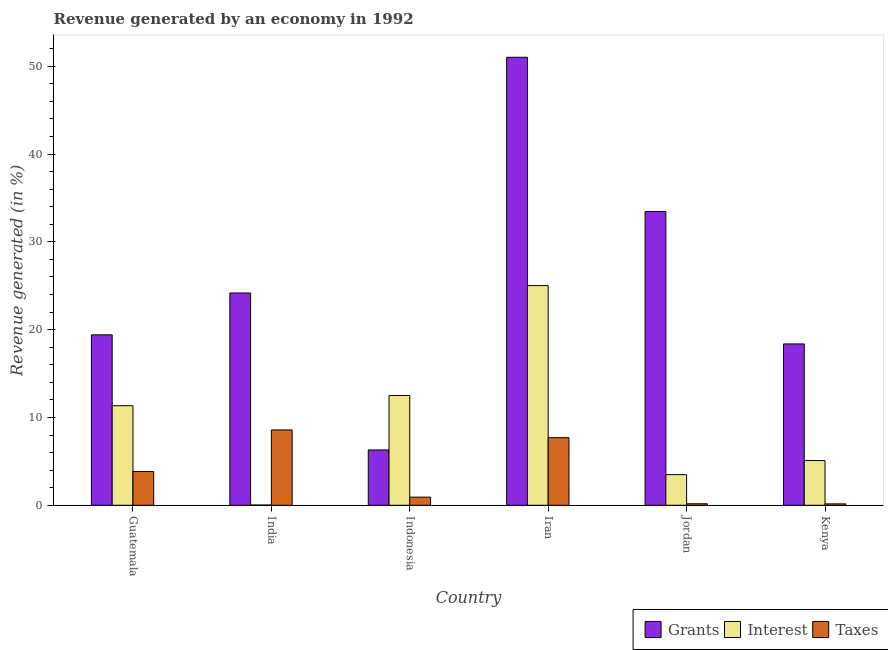How many groups of bars are there?
Keep it short and to the point. 6. Are the number of bars on each tick of the X-axis equal?
Make the answer very short. Yes. How many bars are there on the 5th tick from the right?
Offer a terse response. 3. What is the label of the 4th group of bars from the left?
Your response must be concise. Iran. What is the percentage of revenue generated by taxes in Iran?
Your response must be concise. 7.7. Across all countries, what is the maximum percentage of revenue generated by taxes?
Offer a terse response. 8.58. Across all countries, what is the minimum percentage of revenue generated by grants?
Keep it short and to the point. 6.3. In which country was the percentage of revenue generated by taxes maximum?
Make the answer very short. India. What is the total percentage of revenue generated by grants in the graph?
Provide a short and direct response. 152.74. What is the difference between the percentage of revenue generated by taxes in India and that in Indonesia?
Your answer should be very brief. 7.65. What is the difference between the percentage of revenue generated by grants in Iran and the percentage of revenue generated by taxes in Jordan?
Ensure brevity in your answer.  50.85. What is the average percentage of revenue generated by taxes per country?
Offer a very short reply. 3.56. What is the difference between the percentage of revenue generated by interest and percentage of revenue generated by grants in Iran?
Your answer should be compact. -26. In how many countries, is the percentage of revenue generated by grants greater than 36 %?
Offer a terse response. 1. What is the ratio of the percentage of revenue generated by interest in Indonesia to that in Iran?
Provide a short and direct response. 0.5. Is the percentage of revenue generated by interest in Iran less than that in Kenya?
Give a very brief answer. No. What is the difference between the highest and the second highest percentage of revenue generated by grants?
Keep it short and to the point. 17.56. What is the difference between the highest and the lowest percentage of revenue generated by taxes?
Make the answer very short. 8.42. Is the sum of the percentage of revenue generated by grants in Guatemala and Indonesia greater than the maximum percentage of revenue generated by interest across all countries?
Your answer should be very brief. Yes. What does the 1st bar from the left in India represents?
Offer a terse response. Grants. What does the 2nd bar from the right in Kenya represents?
Make the answer very short. Interest. Is it the case that in every country, the sum of the percentage of revenue generated by grants and percentage of revenue generated by interest is greater than the percentage of revenue generated by taxes?
Offer a terse response. Yes. How many countries are there in the graph?
Your answer should be very brief. 6. Are the values on the major ticks of Y-axis written in scientific E-notation?
Offer a very short reply. No. Does the graph contain any zero values?
Your answer should be compact. No. Does the graph contain grids?
Provide a succinct answer. No. What is the title of the graph?
Your response must be concise. Revenue generated by an economy in 1992. Does "Negligence towards kids" appear as one of the legend labels in the graph?
Provide a succinct answer. No. What is the label or title of the X-axis?
Provide a short and direct response. Country. What is the label or title of the Y-axis?
Make the answer very short. Revenue generated (in %). What is the Revenue generated (in %) of Grants in Guatemala?
Keep it short and to the point. 19.41. What is the Revenue generated (in %) in Interest in Guatemala?
Offer a very short reply. 11.34. What is the Revenue generated (in %) in Taxes in Guatemala?
Make the answer very short. 3.84. What is the Revenue generated (in %) of Grants in India?
Provide a succinct answer. 24.18. What is the Revenue generated (in %) of Interest in India?
Offer a very short reply. 0.02. What is the Revenue generated (in %) in Taxes in India?
Provide a succinct answer. 8.58. What is the Revenue generated (in %) of Grants in Indonesia?
Offer a very short reply. 6.3. What is the Revenue generated (in %) in Interest in Indonesia?
Your answer should be compact. 12.5. What is the Revenue generated (in %) of Taxes in Indonesia?
Offer a terse response. 0.93. What is the Revenue generated (in %) of Grants in Iran?
Offer a terse response. 51.02. What is the Revenue generated (in %) of Interest in Iran?
Provide a short and direct response. 25.02. What is the Revenue generated (in %) in Taxes in Iran?
Keep it short and to the point. 7.7. What is the Revenue generated (in %) in Grants in Jordan?
Make the answer very short. 33.46. What is the Revenue generated (in %) of Interest in Jordan?
Ensure brevity in your answer.  3.49. What is the Revenue generated (in %) of Taxes in Jordan?
Provide a succinct answer. 0.17. What is the Revenue generated (in %) in Grants in Kenya?
Make the answer very short. 18.37. What is the Revenue generated (in %) in Interest in Kenya?
Your response must be concise. 5.09. What is the Revenue generated (in %) in Taxes in Kenya?
Provide a short and direct response. 0.16. Across all countries, what is the maximum Revenue generated (in %) of Grants?
Make the answer very short. 51.02. Across all countries, what is the maximum Revenue generated (in %) of Interest?
Ensure brevity in your answer.  25.02. Across all countries, what is the maximum Revenue generated (in %) in Taxes?
Keep it short and to the point. 8.58. Across all countries, what is the minimum Revenue generated (in %) of Grants?
Your response must be concise. 6.3. Across all countries, what is the minimum Revenue generated (in %) of Interest?
Offer a terse response. 0.02. Across all countries, what is the minimum Revenue generated (in %) in Taxes?
Keep it short and to the point. 0.16. What is the total Revenue generated (in %) in Grants in the graph?
Make the answer very short. 152.74. What is the total Revenue generated (in %) in Interest in the graph?
Keep it short and to the point. 57.46. What is the total Revenue generated (in %) in Taxes in the graph?
Offer a very short reply. 21.38. What is the difference between the Revenue generated (in %) in Grants in Guatemala and that in India?
Provide a short and direct response. -4.76. What is the difference between the Revenue generated (in %) of Interest in Guatemala and that in India?
Ensure brevity in your answer.  11.32. What is the difference between the Revenue generated (in %) in Taxes in Guatemala and that in India?
Ensure brevity in your answer.  -4.73. What is the difference between the Revenue generated (in %) of Grants in Guatemala and that in Indonesia?
Your response must be concise. 13.11. What is the difference between the Revenue generated (in %) in Interest in Guatemala and that in Indonesia?
Your answer should be compact. -1.16. What is the difference between the Revenue generated (in %) in Taxes in Guatemala and that in Indonesia?
Provide a succinct answer. 2.92. What is the difference between the Revenue generated (in %) of Grants in Guatemala and that in Iran?
Provide a succinct answer. -31.61. What is the difference between the Revenue generated (in %) in Interest in Guatemala and that in Iran?
Your answer should be compact. -13.68. What is the difference between the Revenue generated (in %) of Taxes in Guatemala and that in Iran?
Offer a terse response. -3.85. What is the difference between the Revenue generated (in %) in Grants in Guatemala and that in Jordan?
Give a very brief answer. -14.04. What is the difference between the Revenue generated (in %) of Interest in Guatemala and that in Jordan?
Your answer should be compact. 7.85. What is the difference between the Revenue generated (in %) in Taxes in Guatemala and that in Jordan?
Your answer should be very brief. 3.67. What is the difference between the Revenue generated (in %) of Grants in Guatemala and that in Kenya?
Offer a very short reply. 1.04. What is the difference between the Revenue generated (in %) in Interest in Guatemala and that in Kenya?
Ensure brevity in your answer.  6.25. What is the difference between the Revenue generated (in %) of Taxes in Guatemala and that in Kenya?
Offer a very short reply. 3.68. What is the difference between the Revenue generated (in %) of Grants in India and that in Indonesia?
Provide a succinct answer. 17.88. What is the difference between the Revenue generated (in %) of Interest in India and that in Indonesia?
Keep it short and to the point. -12.47. What is the difference between the Revenue generated (in %) in Taxes in India and that in Indonesia?
Ensure brevity in your answer.  7.65. What is the difference between the Revenue generated (in %) of Grants in India and that in Iran?
Offer a terse response. -26.84. What is the difference between the Revenue generated (in %) in Interest in India and that in Iran?
Make the answer very short. -25. What is the difference between the Revenue generated (in %) of Taxes in India and that in Iran?
Your answer should be very brief. 0.88. What is the difference between the Revenue generated (in %) of Grants in India and that in Jordan?
Ensure brevity in your answer.  -9.28. What is the difference between the Revenue generated (in %) of Interest in India and that in Jordan?
Your answer should be compact. -3.46. What is the difference between the Revenue generated (in %) of Taxes in India and that in Jordan?
Keep it short and to the point. 8.41. What is the difference between the Revenue generated (in %) in Grants in India and that in Kenya?
Keep it short and to the point. 5.8. What is the difference between the Revenue generated (in %) of Interest in India and that in Kenya?
Your answer should be compact. -5.07. What is the difference between the Revenue generated (in %) in Taxes in India and that in Kenya?
Offer a terse response. 8.42. What is the difference between the Revenue generated (in %) of Grants in Indonesia and that in Iran?
Your response must be concise. -44.72. What is the difference between the Revenue generated (in %) in Interest in Indonesia and that in Iran?
Provide a succinct answer. -12.52. What is the difference between the Revenue generated (in %) in Taxes in Indonesia and that in Iran?
Make the answer very short. -6.77. What is the difference between the Revenue generated (in %) of Grants in Indonesia and that in Jordan?
Offer a very short reply. -27.15. What is the difference between the Revenue generated (in %) in Interest in Indonesia and that in Jordan?
Offer a very short reply. 9.01. What is the difference between the Revenue generated (in %) of Taxes in Indonesia and that in Jordan?
Your answer should be compact. 0.75. What is the difference between the Revenue generated (in %) in Grants in Indonesia and that in Kenya?
Make the answer very short. -12.07. What is the difference between the Revenue generated (in %) in Interest in Indonesia and that in Kenya?
Offer a terse response. 7.41. What is the difference between the Revenue generated (in %) of Taxes in Indonesia and that in Kenya?
Your response must be concise. 0.76. What is the difference between the Revenue generated (in %) of Grants in Iran and that in Jordan?
Your answer should be compact. 17.56. What is the difference between the Revenue generated (in %) in Interest in Iran and that in Jordan?
Offer a terse response. 21.53. What is the difference between the Revenue generated (in %) in Taxes in Iran and that in Jordan?
Ensure brevity in your answer.  7.53. What is the difference between the Revenue generated (in %) in Grants in Iran and that in Kenya?
Provide a succinct answer. 32.64. What is the difference between the Revenue generated (in %) in Interest in Iran and that in Kenya?
Your answer should be very brief. 19.93. What is the difference between the Revenue generated (in %) in Taxes in Iran and that in Kenya?
Make the answer very short. 7.54. What is the difference between the Revenue generated (in %) of Grants in Jordan and that in Kenya?
Offer a terse response. 15.08. What is the difference between the Revenue generated (in %) in Interest in Jordan and that in Kenya?
Your response must be concise. -1.6. What is the difference between the Revenue generated (in %) in Taxes in Jordan and that in Kenya?
Ensure brevity in your answer.  0.01. What is the difference between the Revenue generated (in %) in Grants in Guatemala and the Revenue generated (in %) in Interest in India?
Make the answer very short. 19.39. What is the difference between the Revenue generated (in %) in Grants in Guatemala and the Revenue generated (in %) in Taxes in India?
Your answer should be compact. 10.83. What is the difference between the Revenue generated (in %) of Interest in Guatemala and the Revenue generated (in %) of Taxes in India?
Make the answer very short. 2.76. What is the difference between the Revenue generated (in %) in Grants in Guatemala and the Revenue generated (in %) in Interest in Indonesia?
Give a very brief answer. 6.91. What is the difference between the Revenue generated (in %) in Grants in Guatemala and the Revenue generated (in %) in Taxes in Indonesia?
Offer a terse response. 18.49. What is the difference between the Revenue generated (in %) in Interest in Guatemala and the Revenue generated (in %) in Taxes in Indonesia?
Your response must be concise. 10.41. What is the difference between the Revenue generated (in %) in Grants in Guatemala and the Revenue generated (in %) in Interest in Iran?
Ensure brevity in your answer.  -5.61. What is the difference between the Revenue generated (in %) of Grants in Guatemala and the Revenue generated (in %) of Taxes in Iran?
Keep it short and to the point. 11.71. What is the difference between the Revenue generated (in %) in Interest in Guatemala and the Revenue generated (in %) in Taxes in Iran?
Offer a very short reply. 3.64. What is the difference between the Revenue generated (in %) in Grants in Guatemala and the Revenue generated (in %) in Interest in Jordan?
Your answer should be very brief. 15.92. What is the difference between the Revenue generated (in %) in Grants in Guatemala and the Revenue generated (in %) in Taxes in Jordan?
Provide a succinct answer. 19.24. What is the difference between the Revenue generated (in %) of Interest in Guatemala and the Revenue generated (in %) of Taxes in Jordan?
Your answer should be very brief. 11.17. What is the difference between the Revenue generated (in %) in Grants in Guatemala and the Revenue generated (in %) in Interest in Kenya?
Ensure brevity in your answer.  14.32. What is the difference between the Revenue generated (in %) of Grants in Guatemala and the Revenue generated (in %) of Taxes in Kenya?
Keep it short and to the point. 19.25. What is the difference between the Revenue generated (in %) of Interest in Guatemala and the Revenue generated (in %) of Taxes in Kenya?
Give a very brief answer. 11.18. What is the difference between the Revenue generated (in %) of Grants in India and the Revenue generated (in %) of Interest in Indonesia?
Your answer should be very brief. 11.68. What is the difference between the Revenue generated (in %) of Grants in India and the Revenue generated (in %) of Taxes in Indonesia?
Ensure brevity in your answer.  23.25. What is the difference between the Revenue generated (in %) of Interest in India and the Revenue generated (in %) of Taxes in Indonesia?
Your answer should be very brief. -0.9. What is the difference between the Revenue generated (in %) in Grants in India and the Revenue generated (in %) in Interest in Iran?
Keep it short and to the point. -0.84. What is the difference between the Revenue generated (in %) in Grants in India and the Revenue generated (in %) in Taxes in Iran?
Provide a succinct answer. 16.48. What is the difference between the Revenue generated (in %) in Interest in India and the Revenue generated (in %) in Taxes in Iran?
Provide a short and direct response. -7.67. What is the difference between the Revenue generated (in %) in Grants in India and the Revenue generated (in %) in Interest in Jordan?
Provide a short and direct response. 20.69. What is the difference between the Revenue generated (in %) in Grants in India and the Revenue generated (in %) in Taxes in Jordan?
Your answer should be very brief. 24.01. What is the difference between the Revenue generated (in %) in Interest in India and the Revenue generated (in %) in Taxes in Jordan?
Offer a terse response. -0.15. What is the difference between the Revenue generated (in %) of Grants in India and the Revenue generated (in %) of Interest in Kenya?
Keep it short and to the point. 19.08. What is the difference between the Revenue generated (in %) of Grants in India and the Revenue generated (in %) of Taxes in Kenya?
Ensure brevity in your answer.  24.02. What is the difference between the Revenue generated (in %) of Interest in India and the Revenue generated (in %) of Taxes in Kenya?
Provide a succinct answer. -0.14. What is the difference between the Revenue generated (in %) of Grants in Indonesia and the Revenue generated (in %) of Interest in Iran?
Your response must be concise. -18.72. What is the difference between the Revenue generated (in %) of Grants in Indonesia and the Revenue generated (in %) of Taxes in Iran?
Provide a succinct answer. -1.4. What is the difference between the Revenue generated (in %) of Interest in Indonesia and the Revenue generated (in %) of Taxes in Iran?
Your response must be concise. 4.8. What is the difference between the Revenue generated (in %) of Grants in Indonesia and the Revenue generated (in %) of Interest in Jordan?
Your response must be concise. 2.81. What is the difference between the Revenue generated (in %) in Grants in Indonesia and the Revenue generated (in %) in Taxes in Jordan?
Your answer should be very brief. 6.13. What is the difference between the Revenue generated (in %) of Interest in Indonesia and the Revenue generated (in %) of Taxes in Jordan?
Your answer should be compact. 12.33. What is the difference between the Revenue generated (in %) of Grants in Indonesia and the Revenue generated (in %) of Interest in Kenya?
Your response must be concise. 1.21. What is the difference between the Revenue generated (in %) in Grants in Indonesia and the Revenue generated (in %) in Taxes in Kenya?
Keep it short and to the point. 6.14. What is the difference between the Revenue generated (in %) of Interest in Indonesia and the Revenue generated (in %) of Taxes in Kenya?
Your answer should be very brief. 12.34. What is the difference between the Revenue generated (in %) in Grants in Iran and the Revenue generated (in %) in Interest in Jordan?
Provide a short and direct response. 47.53. What is the difference between the Revenue generated (in %) of Grants in Iran and the Revenue generated (in %) of Taxes in Jordan?
Keep it short and to the point. 50.85. What is the difference between the Revenue generated (in %) in Interest in Iran and the Revenue generated (in %) in Taxes in Jordan?
Keep it short and to the point. 24.85. What is the difference between the Revenue generated (in %) in Grants in Iran and the Revenue generated (in %) in Interest in Kenya?
Provide a succinct answer. 45.93. What is the difference between the Revenue generated (in %) in Grants in Iran and the Revenue generated (in %) in Taxes in Kenya?
Give a very brief answer. 50.86. What is the difference between the Revenue generated (in %) of Interest in Iran and the Revenue generated (in %) of Taxes in Kenya?
Provide a succinct answer. 24.86. What is the difference between the Revenue generated (in %) of Grants in Jordan and the Revenue generated (in %) of Interest in Kenya?
Provide a short and direct response. 28.36. What is the difference between the Revenue generated (in %) in Grants in Jordan and the Revenue generated (in %) in Taxes in Kenya?
Offer a terse response. 33.29. What is the difference between the Revenue generated (in %) in Interest in Jordan and the Revenue generated (in %) in Taxes in Kenya?
Your response must be concise. 3.33. What is the average Revenue generated (in %) of Grants per country?
Keep it short and to the point. 25.46. What is the average Revenue generated (in %) of Interest per country?
Give a very brief answer. 9.58. What is the average Revenue generated (in %) in Taxes per country?
Your response must be concise. 3.56. What is the difference between the Revenue generated (in %) in Grants and Revenue generated (in %) in Interest in Guatemala?
Ensure brevity in your answer.  8.07. What is the difference between the Revenue generated (in %) of Grants and Revenue generated (in %) of Taxes in Guatemala?
Give a very brief answer. 15.57. What is the difference between the Revenue generated (in %) in Interest and Revenue generated (in %) in Taxes in Guatemala?
Keep it short and to the point. 7.5. What is the difference between the Revenue generated (in %) in Grants and Revenue generated (in %) in Interest in India?
Your answer should be compact. 24.15. What is the difference between the Revenue generated (in %) in Grants and Revenue generated (in %) in Taxes in India?
Keep it short and to the point. 15.6. What is the difference between the Revenue generated (in %) of Interest and Revenue generated (in %) of Taxes in India?
Provide a short and direct response. -8.55. What is the difference between the Revenue generated (in %) in Grants and Revenue generated (in %) in Interest in Indonesia?
Make the answer very short. -6.2. What is the difference between the Revenue generated (in %) in Grants and Revenue generated (in %) in Taxes in Indonesia?
Provide a succinct answer. 5.37. What is the difference between the Revenue generated (in %) in Interest and Revenue generated (in %) in Taxes in Indonesia?
Keep it short and to the point. 11.57. What is the difference between the Revenue generated (in %) in Grants and Revenue generated (in %) in Interest in Iran?
Your response must be concise. 26. What is the difference between the Revenue generated (in %) of Grants and Revenue generated (in %) of Taxes in Iran?
Offer a very short reply. 43.32. What is the difference between the Revenue generated (in %) of Interest and Revenue generated (in %) of Taxes in Iran?
Offer a terse response. 17.32. What is the difference between the Revenue generated (in %) of Grants and Revenue generated (in %) of Interest in Jordan?
Keep it short and to the point. 29.97. What is the difference between the Revenue generated (in %) in Grants and Revenue generated (in %) in Taxes in Jordan?
Offer a very short reply. 33.28. What is the difference between the Revenue generated (in %) of Interest and Revenue generated (in %) of Taxes in Jordan?
Keep it short and to the point. 3.32. What is the difference between the Revenue generated (in %) of Grants and Revenue generated (in %) of Interest in Kenya?
Ensure brevity in your answer.  13.28. What is the difference between the Revenue generated (in %) of Grants and Revenue generated (in %) of Taxes in Kenya?
Make the answer very short. 18.21. What is the difference between the Revenue generated (in %) in Interest and Revenue generated (in %) in Taxes in Kenya?
Make the answer very short. 4.93. What is the ratio of the Revenue generated (in %) of Grants in Guatemala to that in India?
Offer a terse response. 0.8. What is the ratio of the Revenue generated (in %) of Interest in Guatemala to that in India?
Ensure brevity in your answer.  464.04. What is the ratio of the Revenue generated (in %) of Taxes in Guatemala to that in India?
Ensure brevity in your answer.  0.45. What is the ratio of the Revenue generated (in %) in Grants in Guatemala to that in Indonesia?
Your answer should be compact. 3.08. What is the ratio of the Revenue generated (in %) of Interest in Guatemala to that in Indonesia?
Your response must be concise. 0.91. What is the ratio of the Revenue generated (in %) of Taxes in Guatemala to that in Indonesia?
Provide a short and direct response. 4.15. What is the ratio of the Revenue generated (in %) in Grants in Guatemala to that in Iran?
Provide a succinct answer. 0.38. What is the ratio of the Revenue generated (in %) in Interest in Guatemala to that in Iran?
Ensure brevity in your answer.  0.45. What is the ratio of the Revenue generated (in %) in Taxes in Guatemala to that in Iran?
Keep it short and to the point. 0.5. What is the ratio of the Revenue generated (in %) of Grants in Guatemala to that in Jordan?
Offer a very short reply. 0.58. What is the ratio of the Revenue generated (in %) in Interest in Guatemala to that in Jordan?
Keep it short and to the point. 3.25. What is the ratio of the Revenue generated (in %) of Taxes in Guatemala to that in Jordan?
Provide a succinct answer. 22.49. What is the ratio of the Revenue generated (in %) of Grants in Guatemala to that in Kenya?
Provide a succinct answer. 1.06. What is the ratio of the Revenue generated (in %) of Interest in Guatemala to that in Kenya?
Keep it short and to the point. 2.23. What is the ratio of the Revenue generated (in %) in Taxes in Guatemala to that in Kenya?
Keep it short and to the point. 23.94. What is the ratio of the Revenue generated (in %) in Grants in India to that in Indonesia?
Offer a very short reply. 3.84. What is the ratio of the Revenue generated (in %) in Interest in India to that in Indonesia?
Ensure brevity in your answer.  0. What is the ratio of the Revenue generated (in %) in Taxes in India to that in Indonesia?
Offer a very short reply. 9.27. What is the ratio of the Revenue generated (in %) in Grants in India to that in Iran?
Provide a succinct answer. 0.47. What is the ratio of the Revenue generated (in %) of Interest in India to that in Iran?
Make the answer very short. 0. What is the ratio of the Revenue generated (in %) in Taxes in India to that in Iran?
Provide a short and direct response. 1.11. What is the ratio of the Revenue generated (in %) of Grants in India to that in Jordan?
Offer a terse response. 0.72. What is the ratio of the Revenue generated (in %) of Interest in India to that in Jordan?
Keep it short and to the point. 0.01. What is the ratio of the Revenue generated (in %) of Taxes in India to that in Jordan?
Your answer should be compact. 50.19. What is the ratio of the Revenue generated (in %) of Grants in India to that in Kenya?
Your answer should be compact. 1.32. What is the ratio of the Revenue generated (in %) in Interest in India to that in Kenya?
Provide a short and direct response. 0. What is the ratio of the Revenue generated (in %) of Taxes in India to that in Kenya?
Offer a very short reply. 53.41. What is the ratio of the Revenue generated (in %) in Grants in Indonesia to that in Iran?
Make the answer very short. 0.12. What is the ratio of the Revenue generated (in %) in Interest in Indonesia to that in Iran?
Provide a succinct answer. 0.5. What is the ratio of the Revenue generated (in %) in Taxes in Indonesia to that in Iran?
Offer a terse response. 0.12. What is the ratio of the Revenue generated (in %) in Grants in Indonesia to that in Jordan?
Your answer should be very brief. 0.19. What is the ratio of the Revenue generated (in %) of Interest in Indonesia to that in Jordan?
Keep it short and to the point. 3.58. What is the ratio of the Revenue generated (in %) of Taxes in Indonesia to that in Jordan?
Offer a terse response. 5.41. What is the ratio of the Revenue generated (in %) in Grants in Indonesia to that in Kenya?
Provide a succinct answer. 0.34. What is the ratio of the Revenue generated (in %) in Interest in Indonesia to that in Kenya?
Give a very brief answer. 2.45. What is the ratio of the Revenue generated (in %) in Taxes in Indonesia to that in Kenya?
Provide a succinct answer. 5.76. What is the ratio of the Revenue generated (in %) of Grants in Iran to that in Jordan?
Provide a succinct answer. 1.52. What is the ratio of the Revenue generated (in %) of Interest in Iran to that in Jordan?
Your response must be concise. 7.17. What is the ratio of the Revenue generated (in %) in Taxes in Iran to that in Jordan?
Give a very brief answer. 45.03. What is the ratio of the Revenue generated (in %) in Grants in Iran to that in Kenya?
Your answer should be compact. 2.78. What is the ratio of the Revenue generated (in %) of Interest in Iran to that in Kenya?
Your answer should be very brief. 4.91. What is the ratio of the Revenue generated (in %) of Taxes in Iran to that in Kenya?
Keep it short and to the point. 47.92. What is the ratio of the Revenue generated (in %) of Grants in Jordan to that in Kenya?
Keep it short and to the point. 1.82. What is the ratio of the Revenue generated (in %) in Interest in Jordan to that in Kenya?
Keep it short and to the point. 0.68. What is the ratio of the Revenue generated (in %) in Taxes in Jordan to that in Kenya?
Offer a very short reply. 1.06. What is the difference between the highest and the second highest Revenue generated (in %) of Grants?
Your answer should be very brief. 17.56. What is the difference between the highest and the second highest Revenue generated (in %) in Interest?
Ensure brevity in your answer.  12.52. What is the difference between the highest and the second highest Revenue generated (in %) in Taxes?
Give a very brief answer. 0.88. What is the difference between the highest and the lowest Revenue generated (in %) of Grants?
Offer a very short reply. 44.72. What is the difference between the highest and the lowest Revenue generated (in %) in Interest?
Offer a very short reply. 25. What is the difference between the highest and the lowest Revenue generated (in %) of Taxes?
Keep it short and to the point. 8.42. 